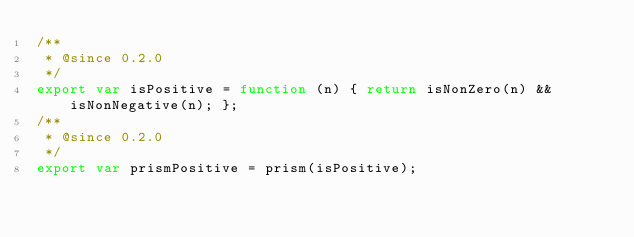Convert code to text. <code><loc_0><loc_0><loc_500><loc_500><_JavaScript_>/**
 * @since 0.2.0
 */
export var isPositive = function (n) { return isNonZero(n) && isNonNegative(n); };
/**
 * @since 0.2.0
 */
export var prismPositive = prism(isPositive);
</code> 